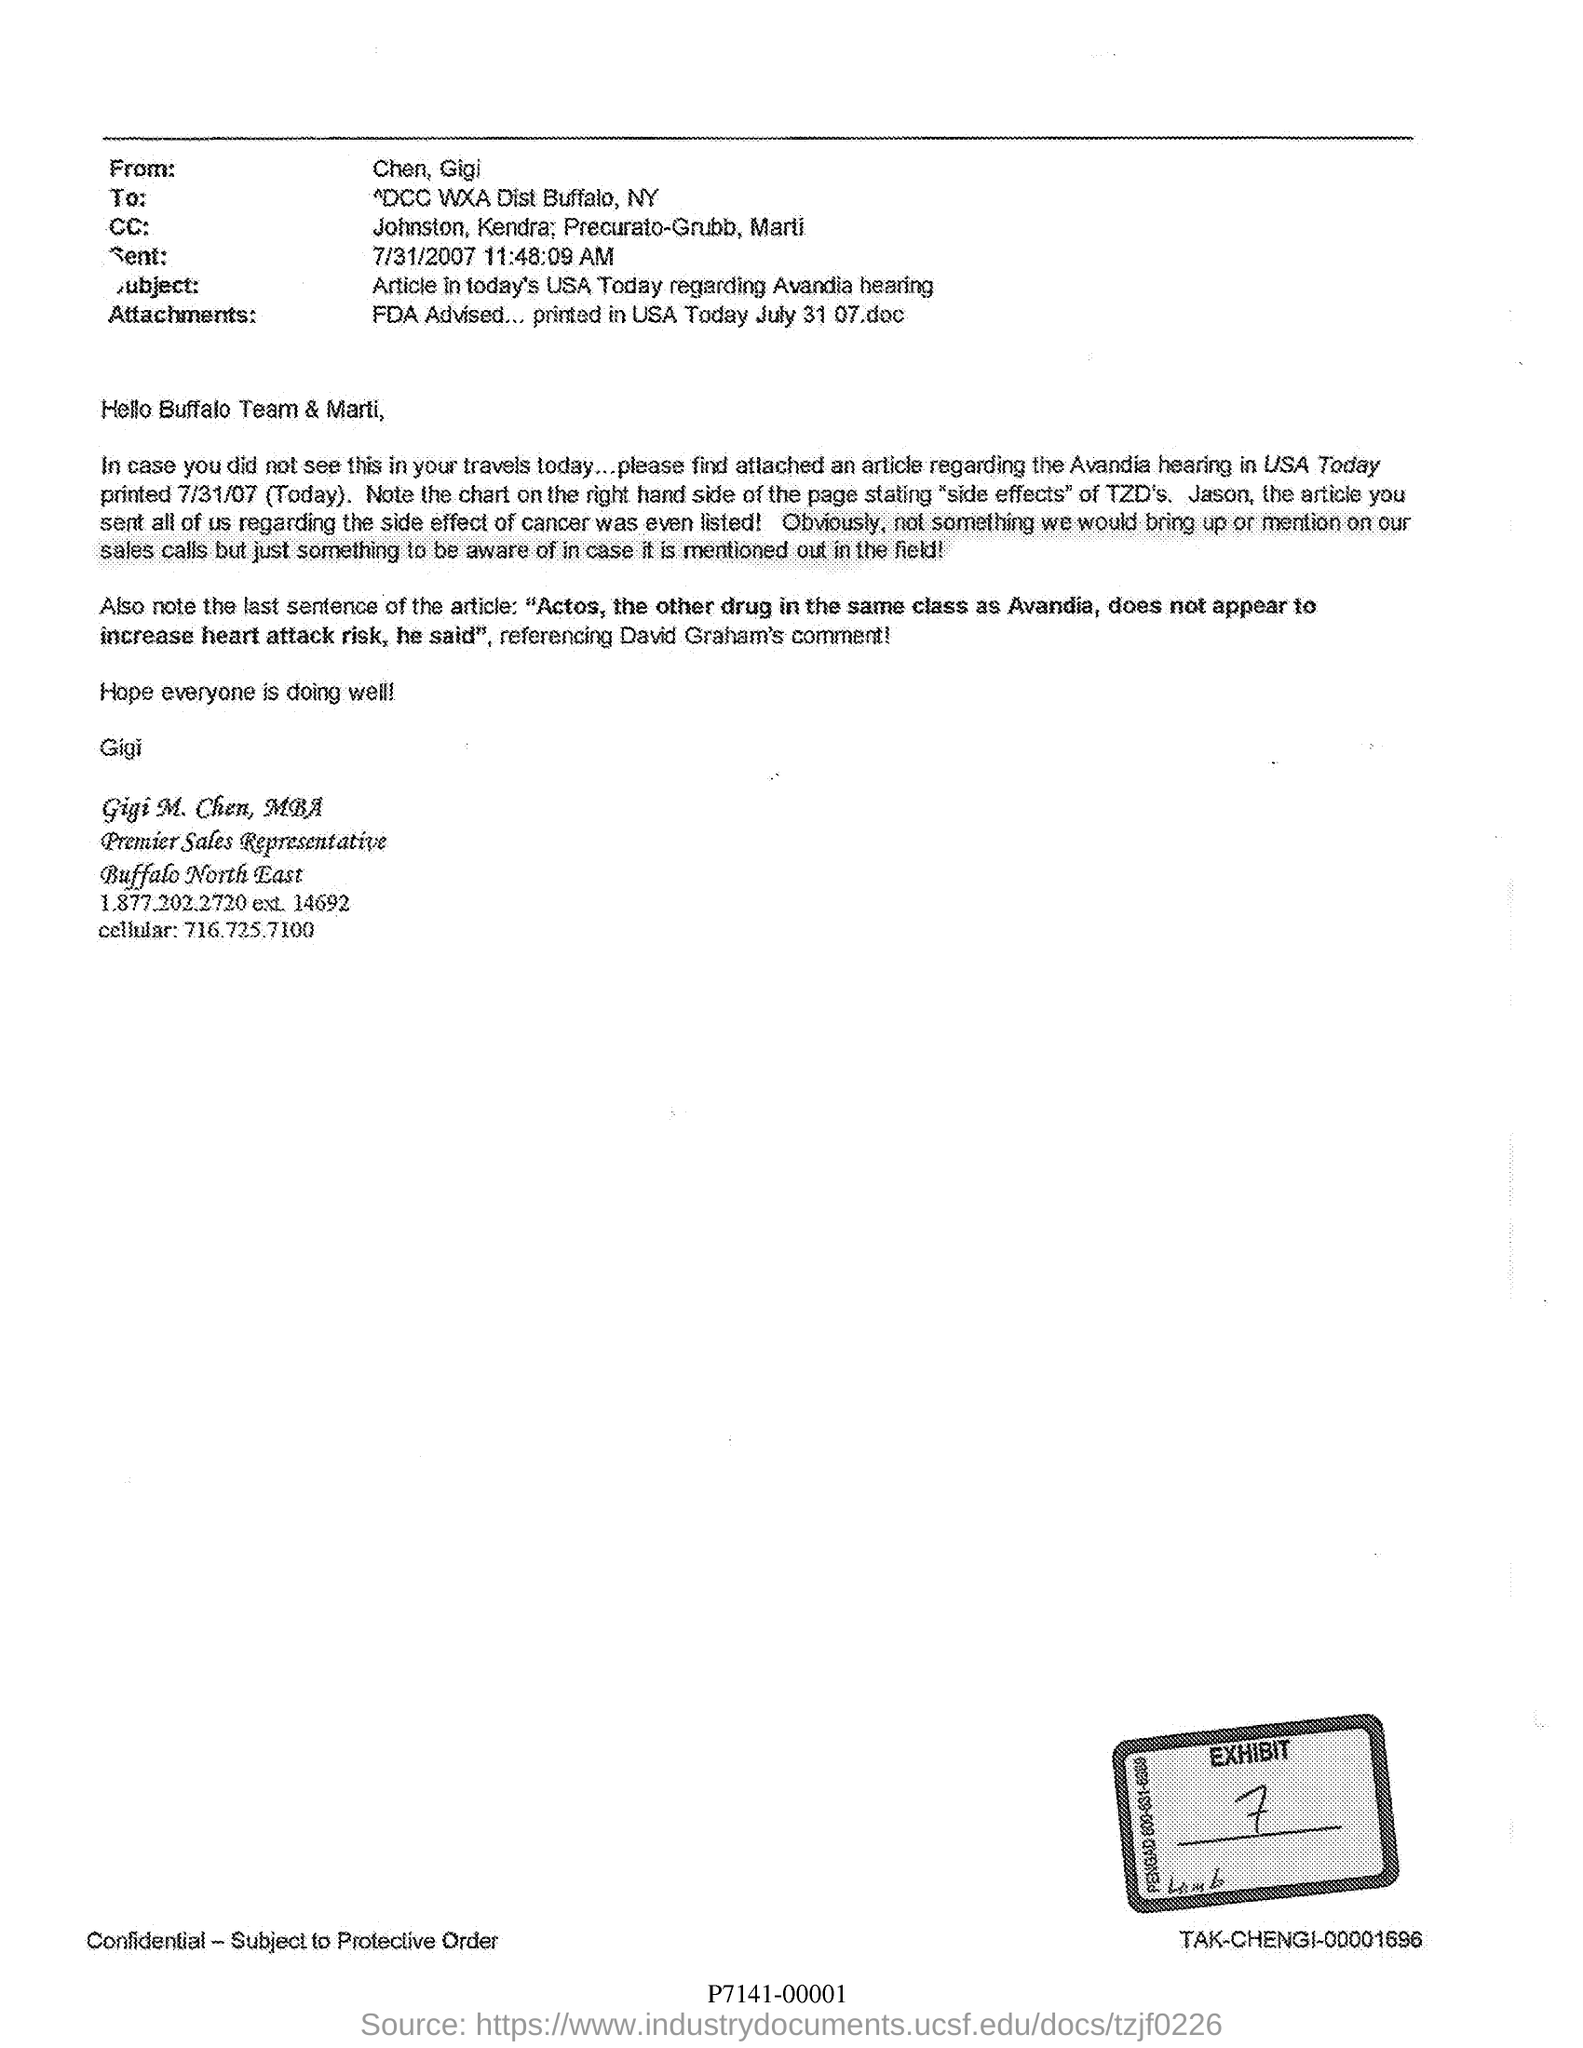Who are in the cc?
Your answer should be compact. Johnston,kendra; precurato-grubb, marti. What is the "subject" of this letter?
Give a very brief answer. Article in today's usa today regarding avandia hearing. Who is writing this letter?
Keep it short and to the point. Gigi m. chen, mba. When was this letter sent?
Provide a succinct answer. 7/31/2007 11:48:09 am. Who is the premier sales representative ?
Keep it short and to the point. Gigi m. chen, mba. What is the cellular number of Gigi M. Chen?
Your answer should be very brief. 716.725.7100. 